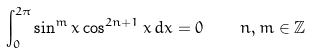Convert formula to latex. <formula><loc_0><loc_0><loc_500><loc_500>\int _ { 0 } ^ { 2 \pi } \sin ^ { m } { x } \cos ^ { 2 n + 1 } { x } \, d x = 0 \, \quad n , m \in \mathbb { Z }</formula> 